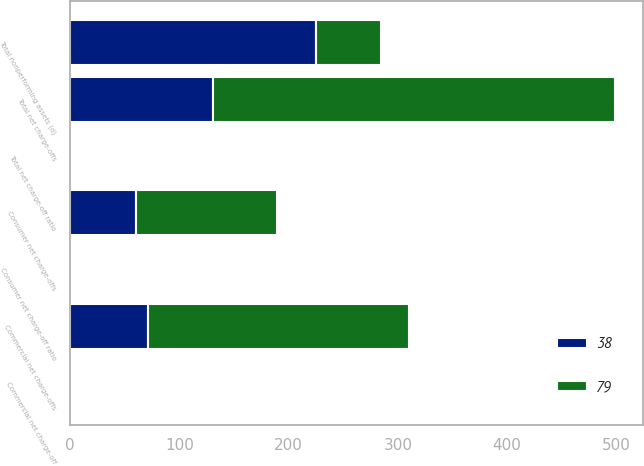Convert chart to OTSL. <chart><loc_0><loc_0><loc_500><loc_500><stacked_bar_chart><ecel><fcel>Total nonperforming assets (d)<fcel>Commercial net charge-offs<fcel>Consumer net charge-offs<fcel>Total net charge-offs<fcel>Commercial net charge-off<fcel>Consumer net charge-off ratio<fcel>Total net charge-off ratio<nl><fcel>79<fcel>60<fcel>239<fcel>129<fcel>368<fcel>1.52<fcel>0.56<fcel>0.95<nl><fcel>38<fcel>225<fcel>71<fcel>60<fcel>131<fcel>0.52<fcel>0.3<fcel>0.39<nl></chart> 